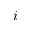<formula> <loc_0><loc_0><loc_500><loc_500>i</formula> 